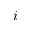<formula> <loc_0><loc_0><loc_500><loc_500>i</formula> 